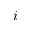<formula> <loc_0><loc_0><loc_500><loc_500>i</formula> 